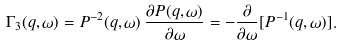Convert formula to latex. <formula><loc_0><loc_0><loc_500><loc_500>\Gamma _ { 3 } ( { q } , \omega ) = P ^ { - 2 } ( { q } , \omega ) \, \frac { \partial P ( { q } , \omega ) } { \partial \omega } = - \frac { \partial } { \partial \omega } [ P ^ { - 1 } ( { q } , \omega ) ] .</formula> 